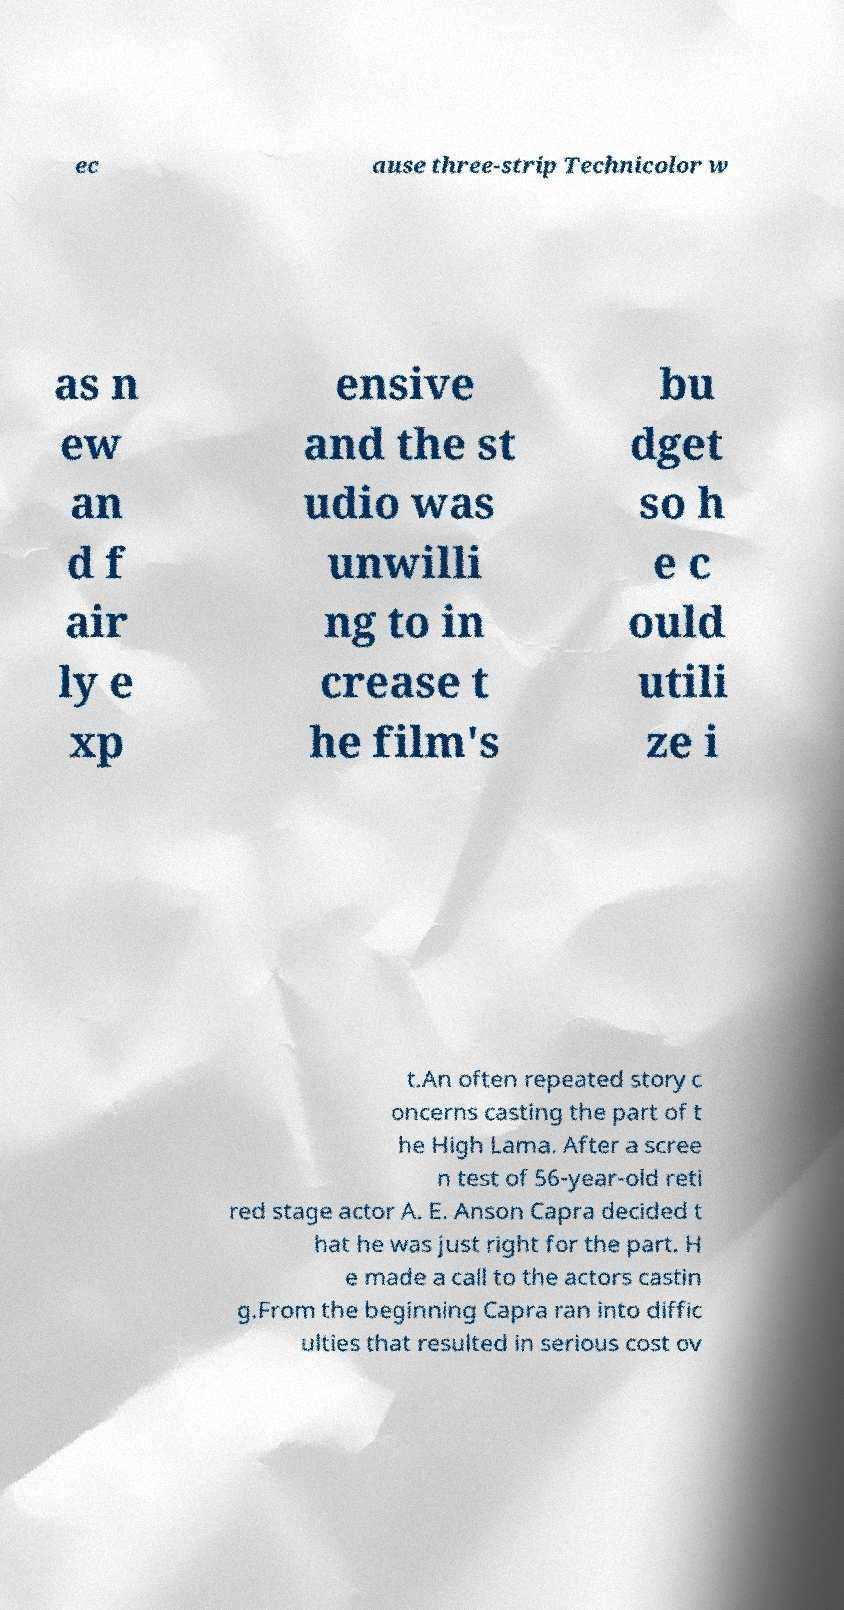For documentation purposes, I need the text within this image transcribed. Could you provide that? ec ause three-strip Technicolor w as n ew an d f air ly e xp ensive and the st udio was unwilli ng to in crease t he film's bu dget so h e c ould utili ze i t.An often repeated story c oncerns casting the part of t he High Lama. After a scree n test of 56-year-old reti red stage actor A. E. Anson Capra decided t hat he was just right for the part. H e made a call to the actors castin g.From the beginning Capra ran into diffic ulties that resulted in serious cost ov 